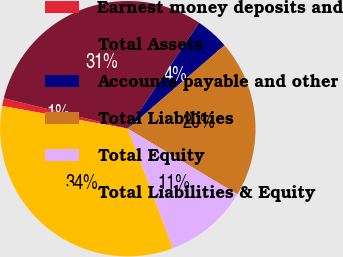<chart> <loc_0><loc_0><loc_500><loc_500><pie_chart><fcel>Earnest money deposits and<fcel>Total Assets<fcel>Accounts payable and other<fcel>Total Liabilities<fcel>Total Equity<fcel>Total Liabilities & Equity<nl><fcel>0.98%<fcel>30.6%<fcel>4.24%<fcel>19.91%<fcel>10.7%<fcel>33.57%<nl></chart> 